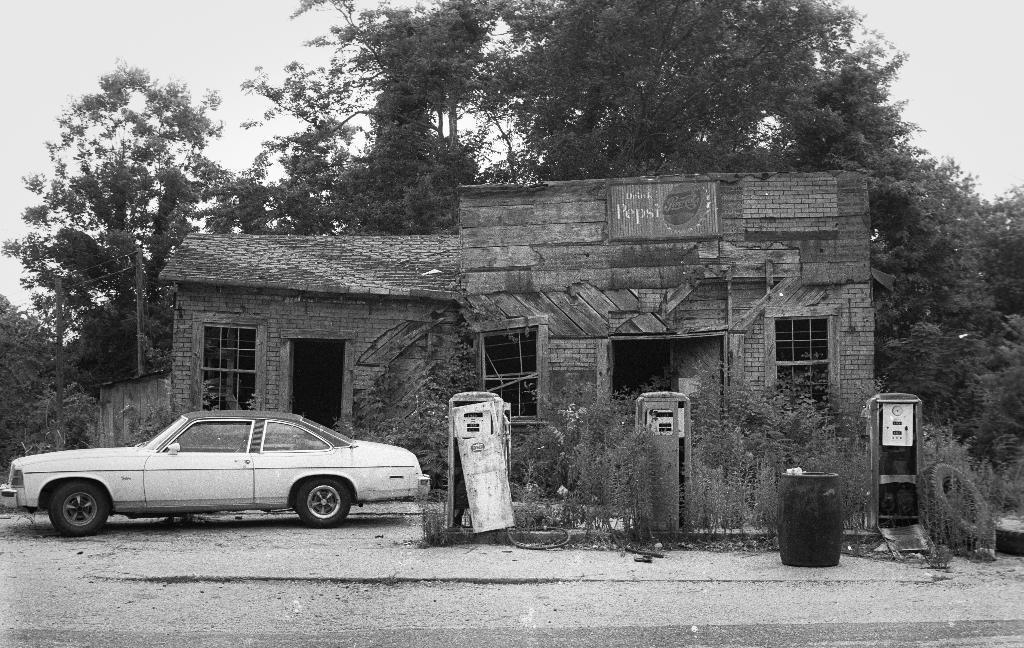Can you describe this image briefly? In this image I can see the car. To the side of the car I can see the machines, plants, dustbin and the house with windows. In the background I can see many trees and the sky. 